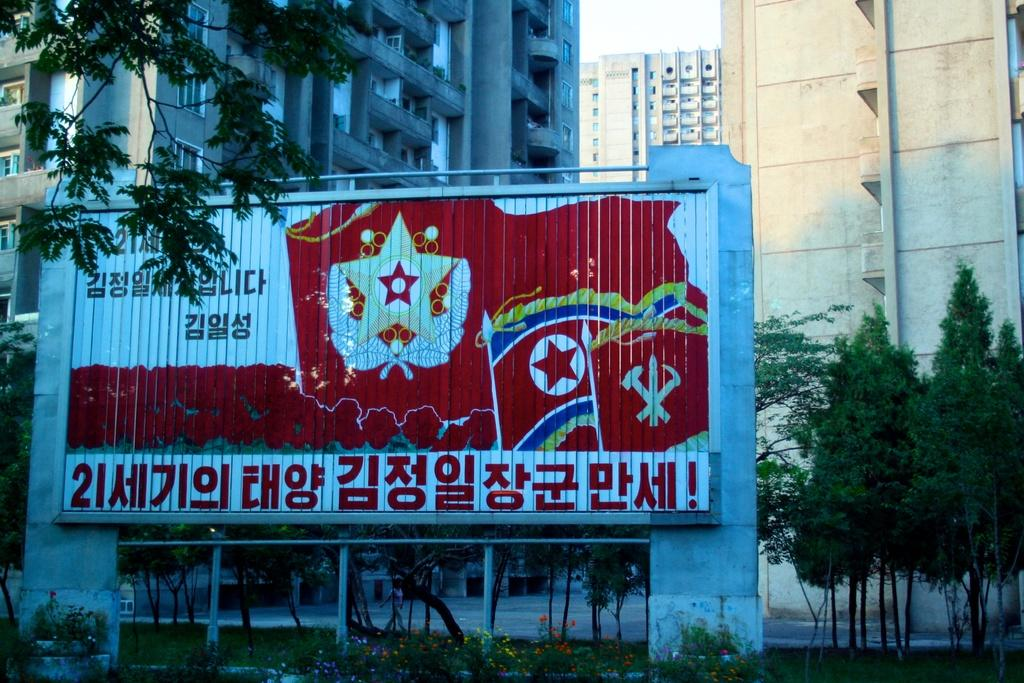What is located on the left side of the image? There is a poster on the left side of the image. What can be seen in the background of the image? There are trees and buildings in the background of the image. What color is the feather on the knee of the person in the image? There is no person or feather present in the image. How many berries are hanging from the trees in the background of the image? There are no berries visible on the trees in the background of the image. 